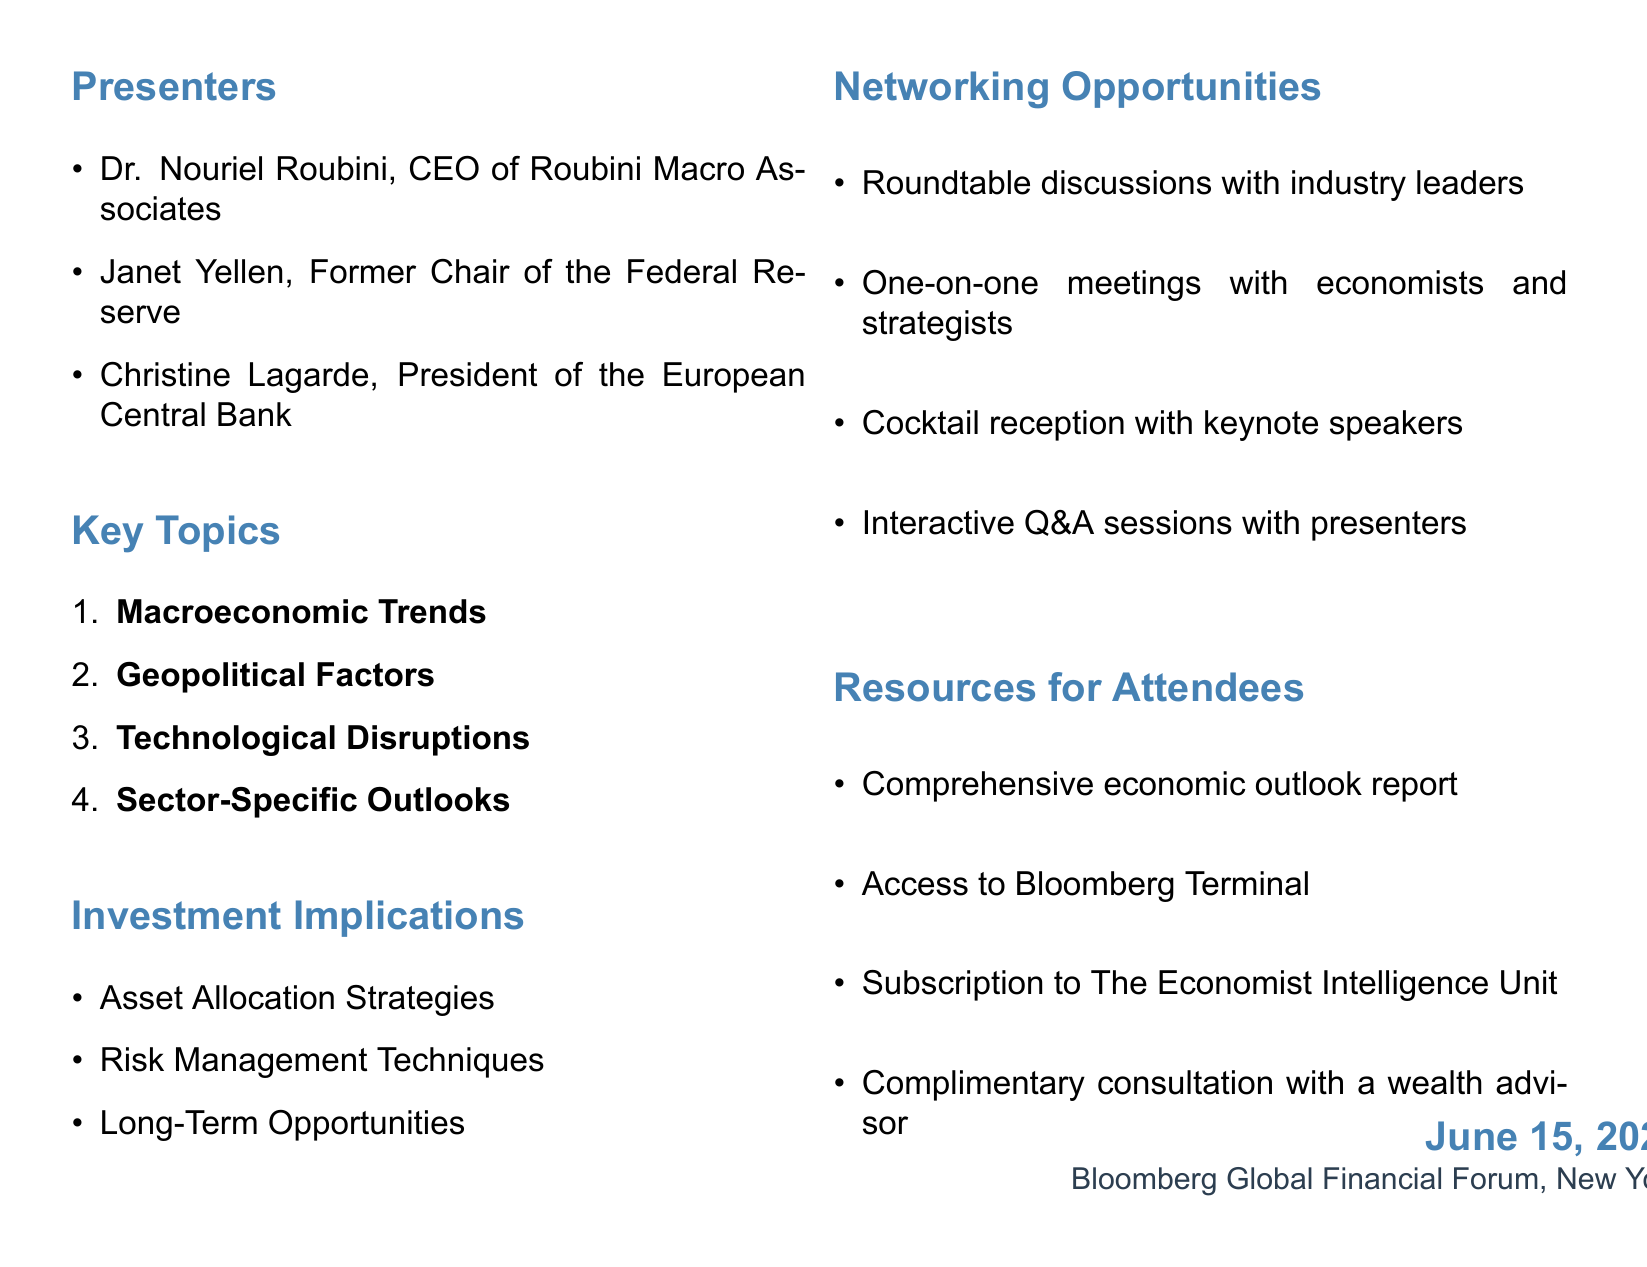What is the title of the presentation? The title is explicitly stated in the overview section of the document.
Answer: Global Economic Outlook: Shaping Long-Term Investment Strategies Who are the presenters? The names of the presenters are listed under the presenters section of the document.
Answer: Dr. Nouriel Roubini, Janet Yellen, Christine Lagarde What date is the presentation scheduled for? The date is mentioned in the overview section of the document.
Answer: June 15, 2023 What is one of the subtopics under Macroeconomic Trends? The document lists several subtopics under Macroeconomic Trends.
Answer: Global GDP growth projections What is a consideration under Risk Management? Various considerations are outlined in the investment implications section, specifically under Risk Management.
Answer: Hedging strategies against currency fluctuations How many key topics are listed in the document? The number of key topics can be counted from the key topics section of the document.
Answer: Four What types of opportunities are available for networking? Networking opportunities are specifically outlined in a dedicated section of the document.
Answer: Roundtable discussions with industry leaders What is one resource provided for attendees? The resources provided for attendees are clearly listed in the resources section.
Answer: Comprehensive economic outlook report by Goldman Sachs Research 